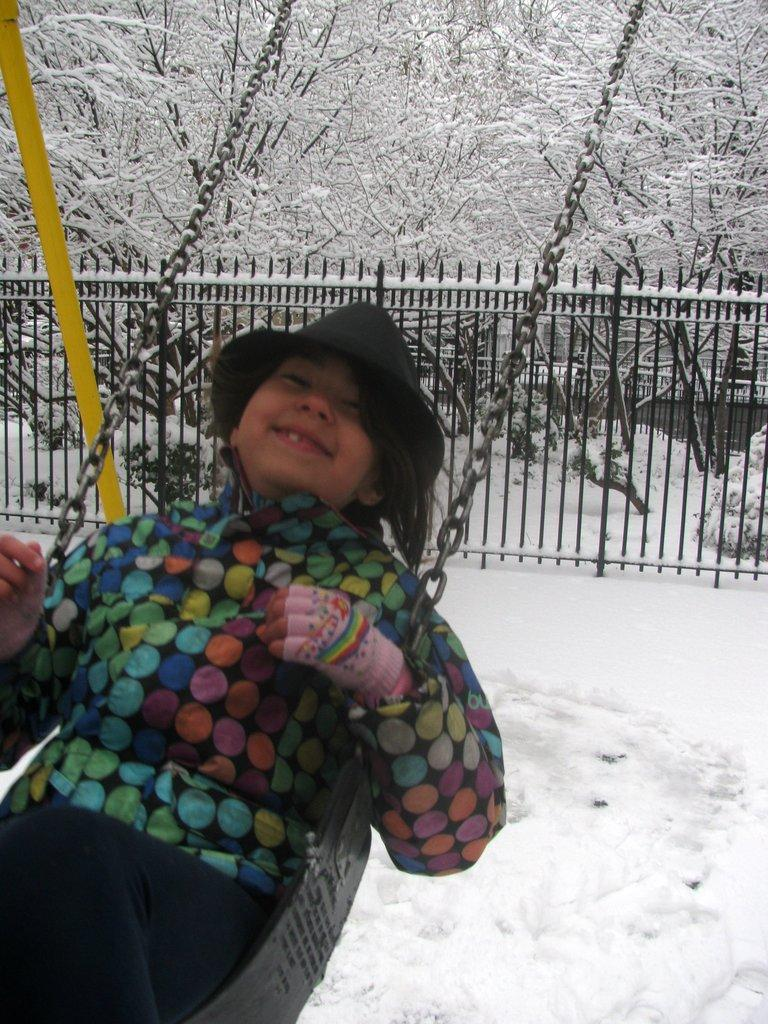What is the main subject of the image? There is a child in the image. What is the child wearing on their hands? The child is wearing gloves. What is the child wearing on their head? The child is wearing a hat. What activity is the child engaged in? The child is on a swing. How is the swing attached to its support? Chains are attached to the swing. What is the weather like in the image? There is snow on the ground, indicating a cold or wintry weather. What can be seen in the background of the image? There are trees and railings in the background. What type of lawyer is standing behind the child in the image? There is no lawyer present in the image. What direction is the child facing in the image? The image does not provide information about the direction the child is facing. 